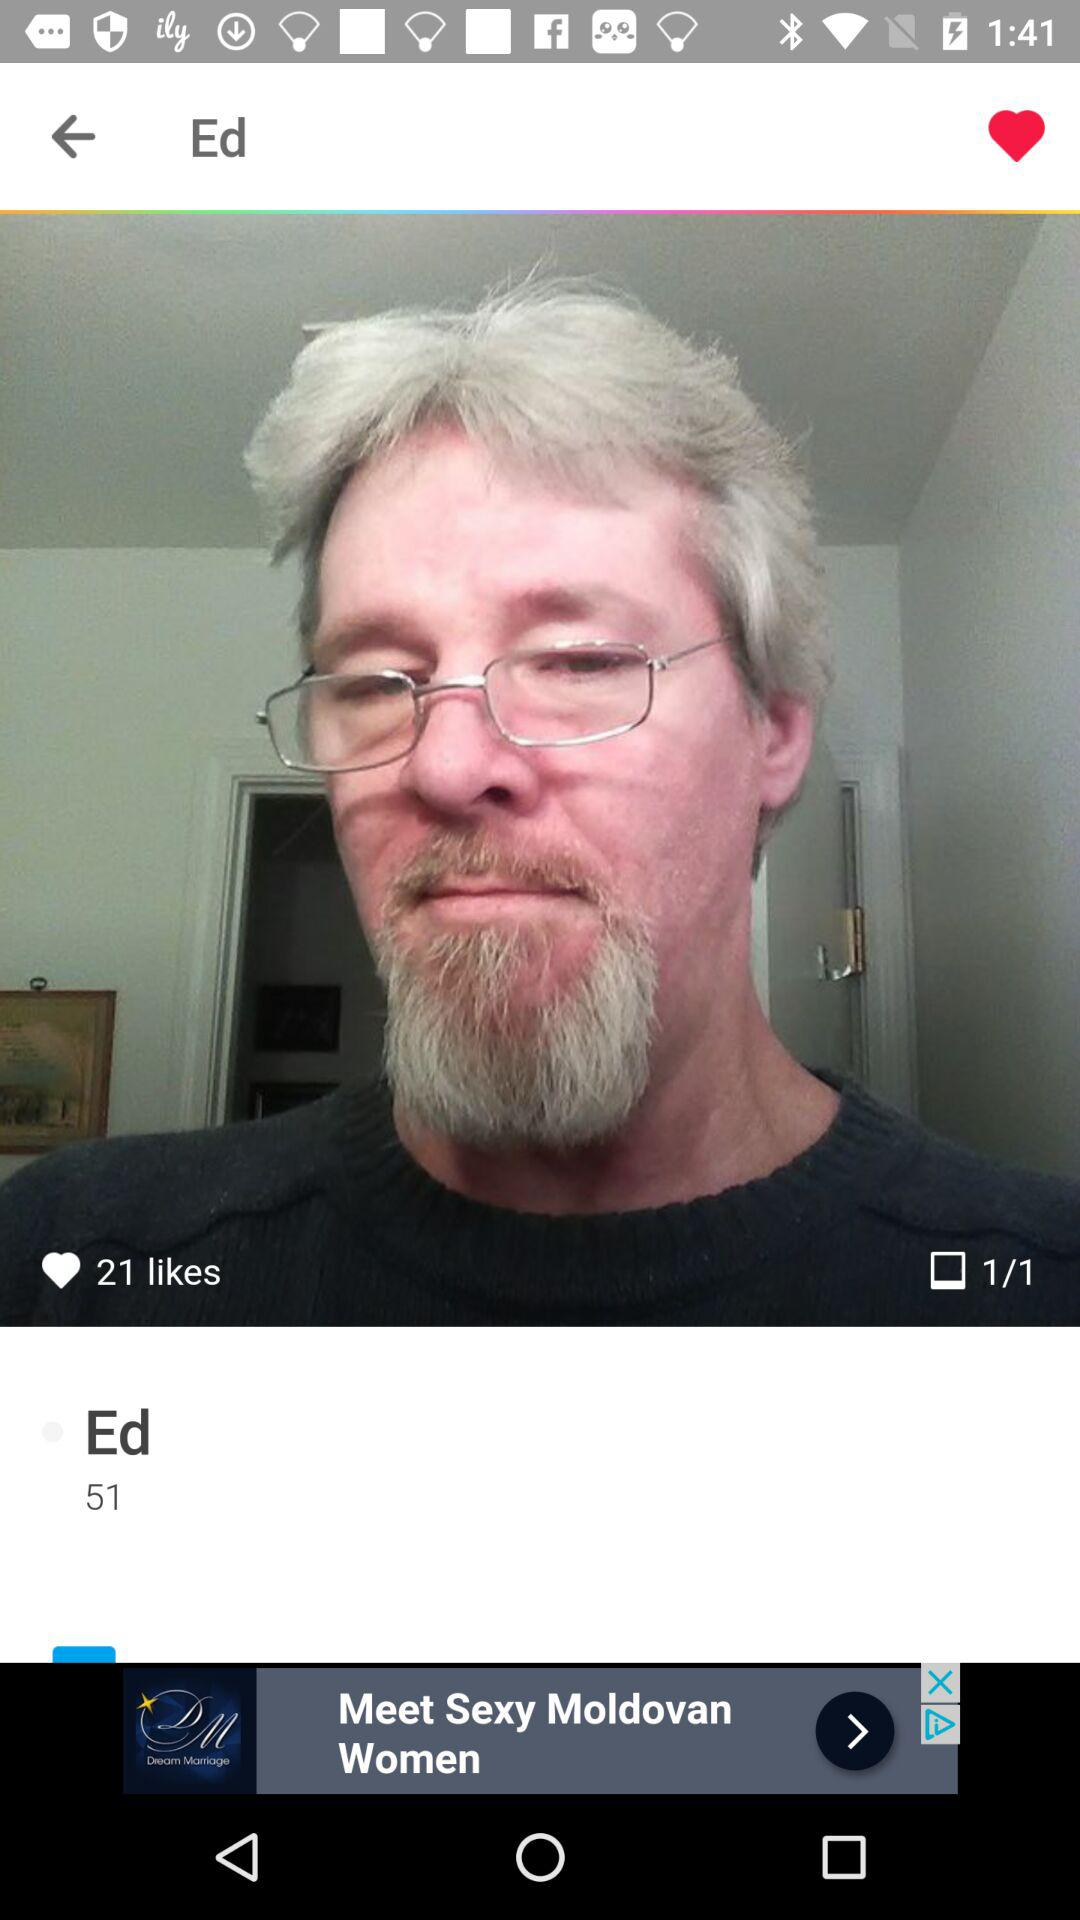What is the age of Ed? Ed is 51 years old. 